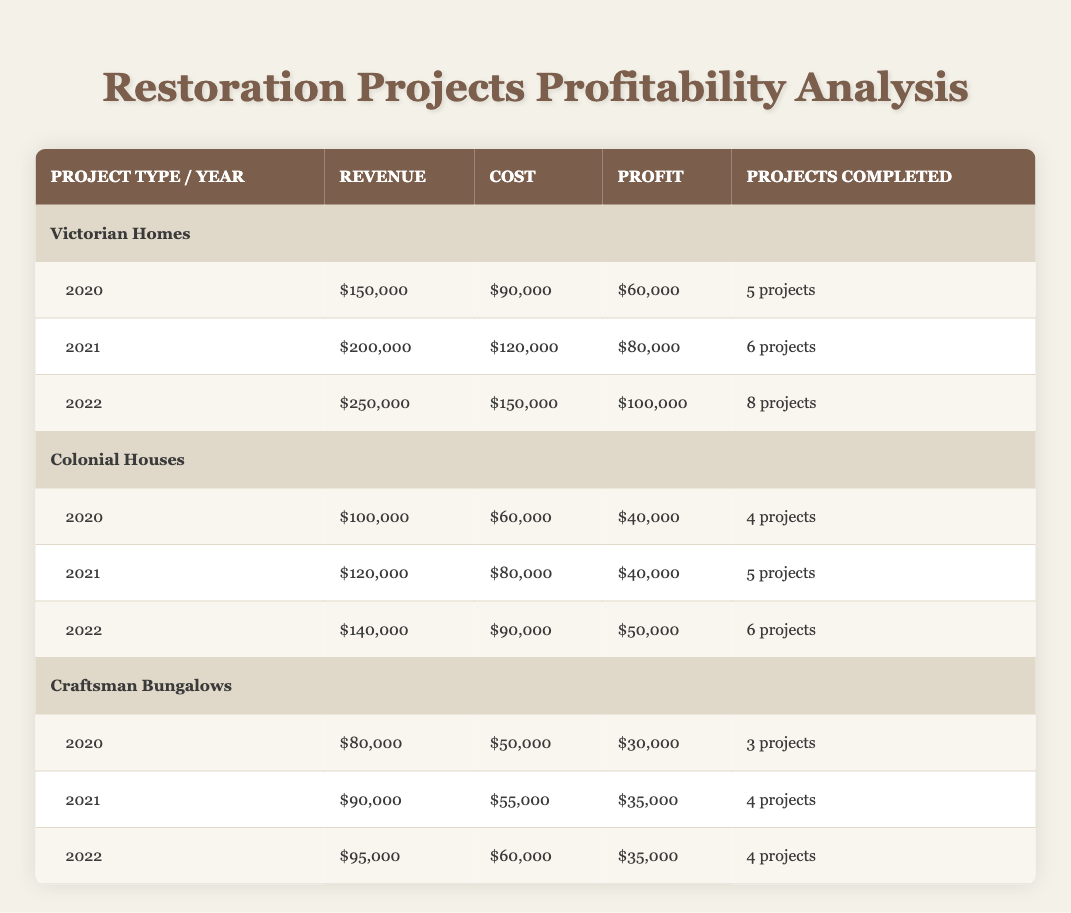What was the profit for Victorian Homes in 2021? According to the table, for the year 2021, the profit for Victorian Homes is listed as $80,000. This is a direct retrieval of the information from the relevant row.
Answer: 80,000 How much revenue was generated from Colonial Houses in 2022? From the table, the revenue for Colonial Houses in 2022 is $140,000. This value can be directly found under the corresponding year and project type.
Answer: 140,000 What is the total profit for Craftsman Bungalows from 2020 to 2022? To calculate the total profit, we add the profits for Craftsman Bungalows for each year: $30,000 (2020) + $35,000 (2021) + $35,000 (2022) = $100,000. Therefore, the total profit over these three years is $100,000.
Answer: 100,000 Did the profit for Colonial Houses in 2021 increase compared to 2020? The profit for Colonial Houses in 2020 is $40,000, and in 2021 it remains the same at $40,000, so there is no increase. This is confirmed by comparing the two figures from the table directly.
Answer: No What was the average cost of restoring Victorian Homes from 2020 to 2022? The costs for Victorian Homes are $90,000 (2020), $120,000 (2021), and $150,000 (2022). First, add these amounts: $90,000 + $120,000 + $150,000 = $360,000. There are 3 entries, so the average cost is $360,000 / 3 = $120,000.
Answer: 120,000 Is the number of projects completed for Craftsman Bungalows higher in 2021 than in 2022? The number of projects completed for Craftsman Bungalows is listed as 4 in 2021 and 4 in 2022. Therefore, the number of completed projects does not exceed between these two years.
Answer: No What was the change in revenue for Colonial Houses from 2020 to 2022? The revenue for Colonial Houses in 2020 was $100,000 and in 2022 it was $140,000. The change in revenue is calculated as $140,000 - $100,000 = $40,000. Thus, there was an increase of $40,000 in revenue over those two years.
Answer: 40,000 How many total projects were completed across all types in 2021? The completed projects in 2021 for each type are: Victorian Homes (6), Colonial Houses (5), and Craftsman Bungalows (4). Adding these together gives: 6 + 5 + 4 = 15 total projects completed in 2021.
Answer: 15 Which project type had the highest profit in 2022? The profits for each type in 2022 are: Victorian Homes ($100,000), Colonial Houses ($50,000), and Craftsman Bungalows ($35,000). Comparing these figures, Victorian Homes had the highest profit of $100,000 in 2022.
Answer: Victorian Homes 